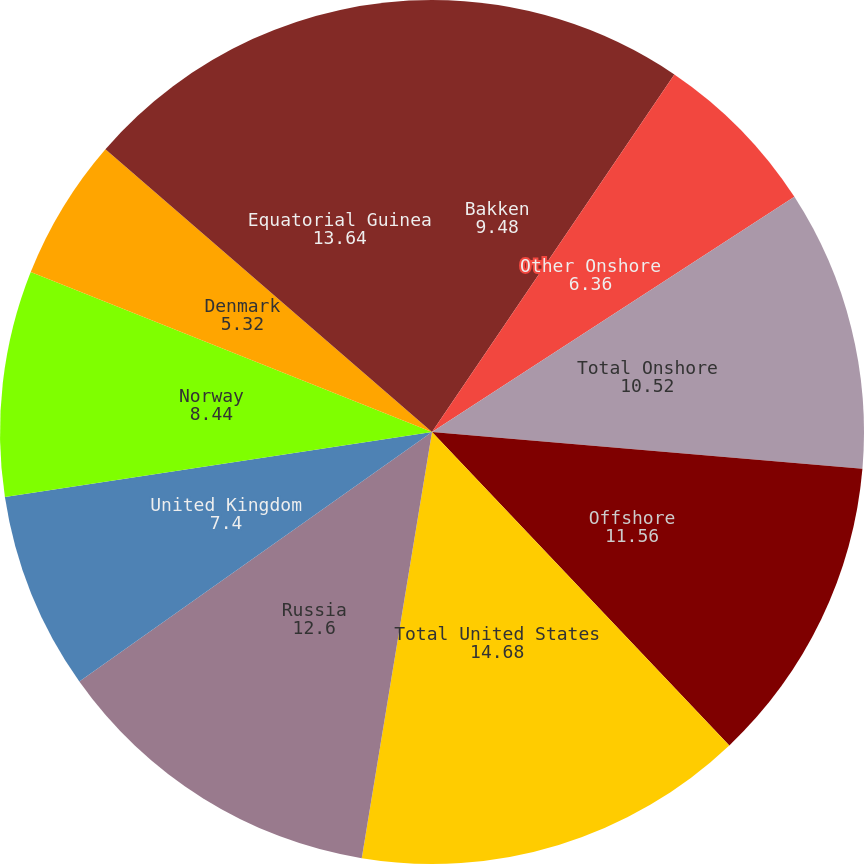Convert chart. <chart><loc_0><loc_0><loc_500><loc_500><pie_chart><fcel>Bakken<fcel>Other Onshore<fcel>Total Onshore<fcel>Offshore<fcel>Total United States<fcel>Russia<fcel>United Kingdom<fcel>Norway<fcel>Denmark<fcel>Equatorial Guinea<nl><fcel>9.48%<fcel>6.36%<fcel>10.52%<fcel>11.56%<fcel>14.68%<fcel>12.6%<fcel>7.4%<fcel>8.44%<fcel>5.32%<fcel>13.64%<nl></chart> 